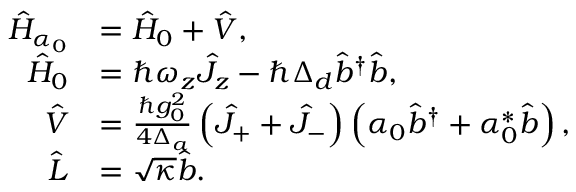<formula> <loc_0><loc_0><loc_500><loc_500>\begin{array} { r l } { \hat { H } _ { \alpha _ { 0 } } } & { = \hat { H } _ { 0 } + \hat { V } , } \\ { \hat { H } _ { 0 } } & { = \hbar { \omega } _ { z } \hat { J } _ { z } - \hbar { \Delta } _ { d } \hat { b } ^ { \dagger } \hat { b } , } \\ { \hat { V } } & { = \frac { \hbar { g } _ { 0 } ^ { 2 } } { 4 \Delta _ { a } } \left ( \hat { J } _ { + } + \hat { J } _ { - } \right ) \left ( \alpha _ { 0 } \hat { b } ^ { \dagger } + \alpha _ { 0 } ^ { * } \hat { b } \right ) , } \\ { \hat { L } } & { = \sqrt { \kappa } \hat { b } . } \end{array}</formula> 